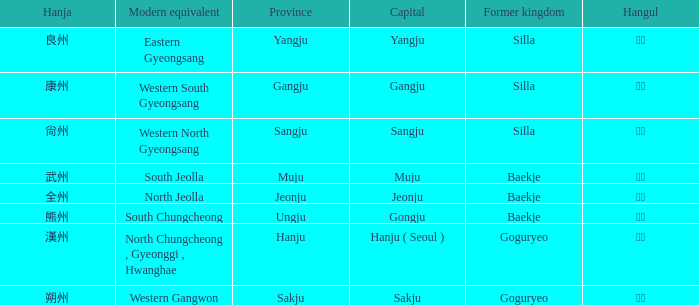What is the modern equivalent of the former kingdom "silla" with the hanja 尙州? 1.0. 